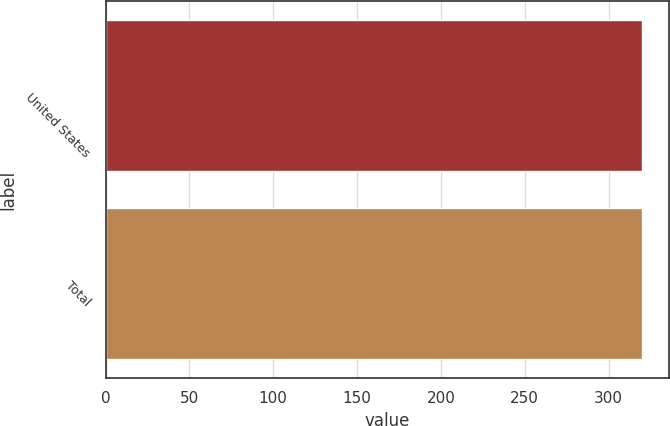Convert chart to OTSL. <chart><loc_0><loc_0><loc_500><loc_500><bar_chart><fcel>United States<fcel>Total<nl><fcel>319.8<fcel>319.9<nl></chart> 